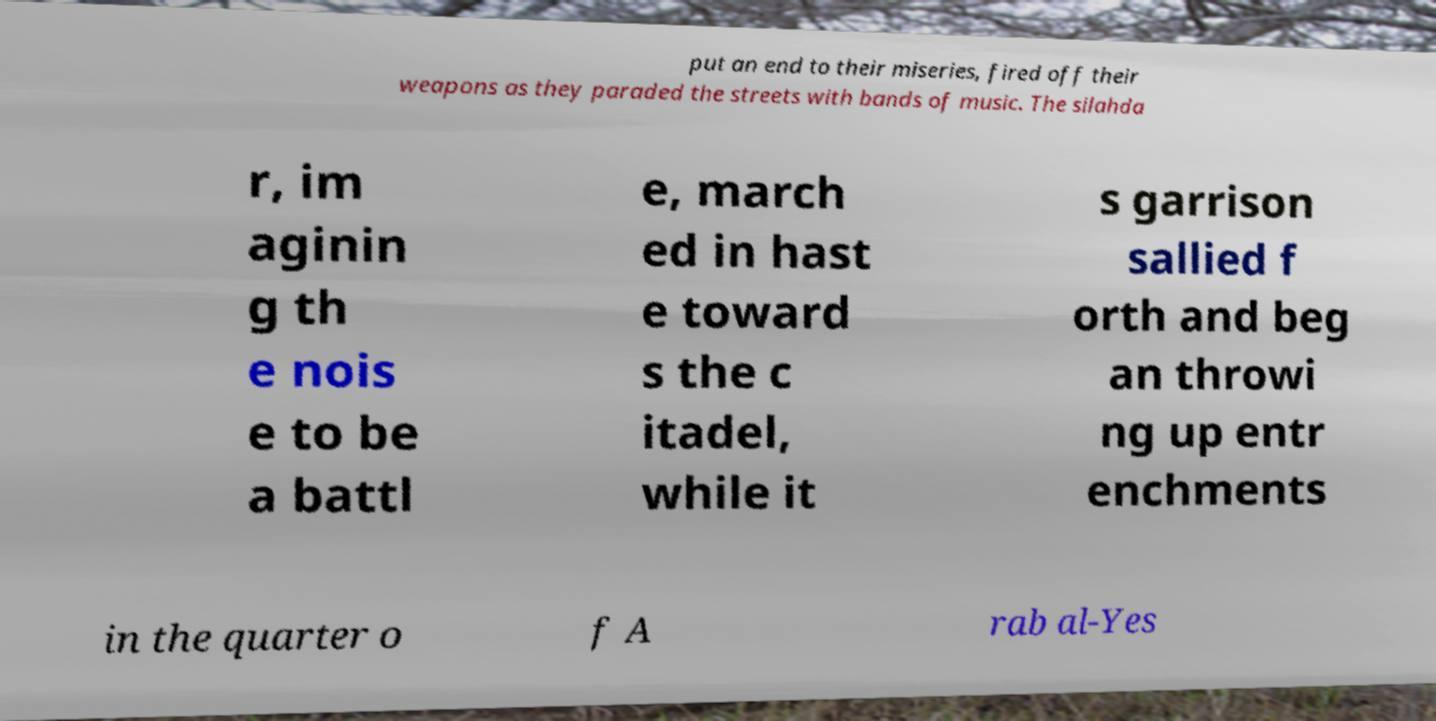What messages or text are displayed in this image? I need them in a readable, typed format. put an end to their miseries, fired off their weapons as they paraded the streets with bands of music. The silahda r, im aginin g th e nois e to be a battl e, march ed in hast e toward s the c itadel, while it s garrison sallied f orth and beg an throwi ng up entr enchments in the quarter o f A rab al-Yes 